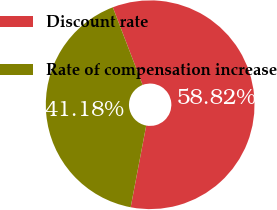<chart> <loc_0><loc_0><loc_500><loc_500><pie_chart><fcel>Discount rate<fcel>Rate of compensation increase<nl><fcel>58.82%<fcel>41.18%<nl></chart> 